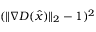Convert formula to latex. <formula><loc_0><loc_0><loc_500><loc_500>( \| \nabla D ( \hat { x } ) \| _ { 2 } - 1 ) ^ { 2 }</formula> 